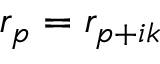Convert formula to latex. <formula><loc_0><loc_0><loc_500><loc_500>r _ { p } = r _ { p + i k }</formula> 